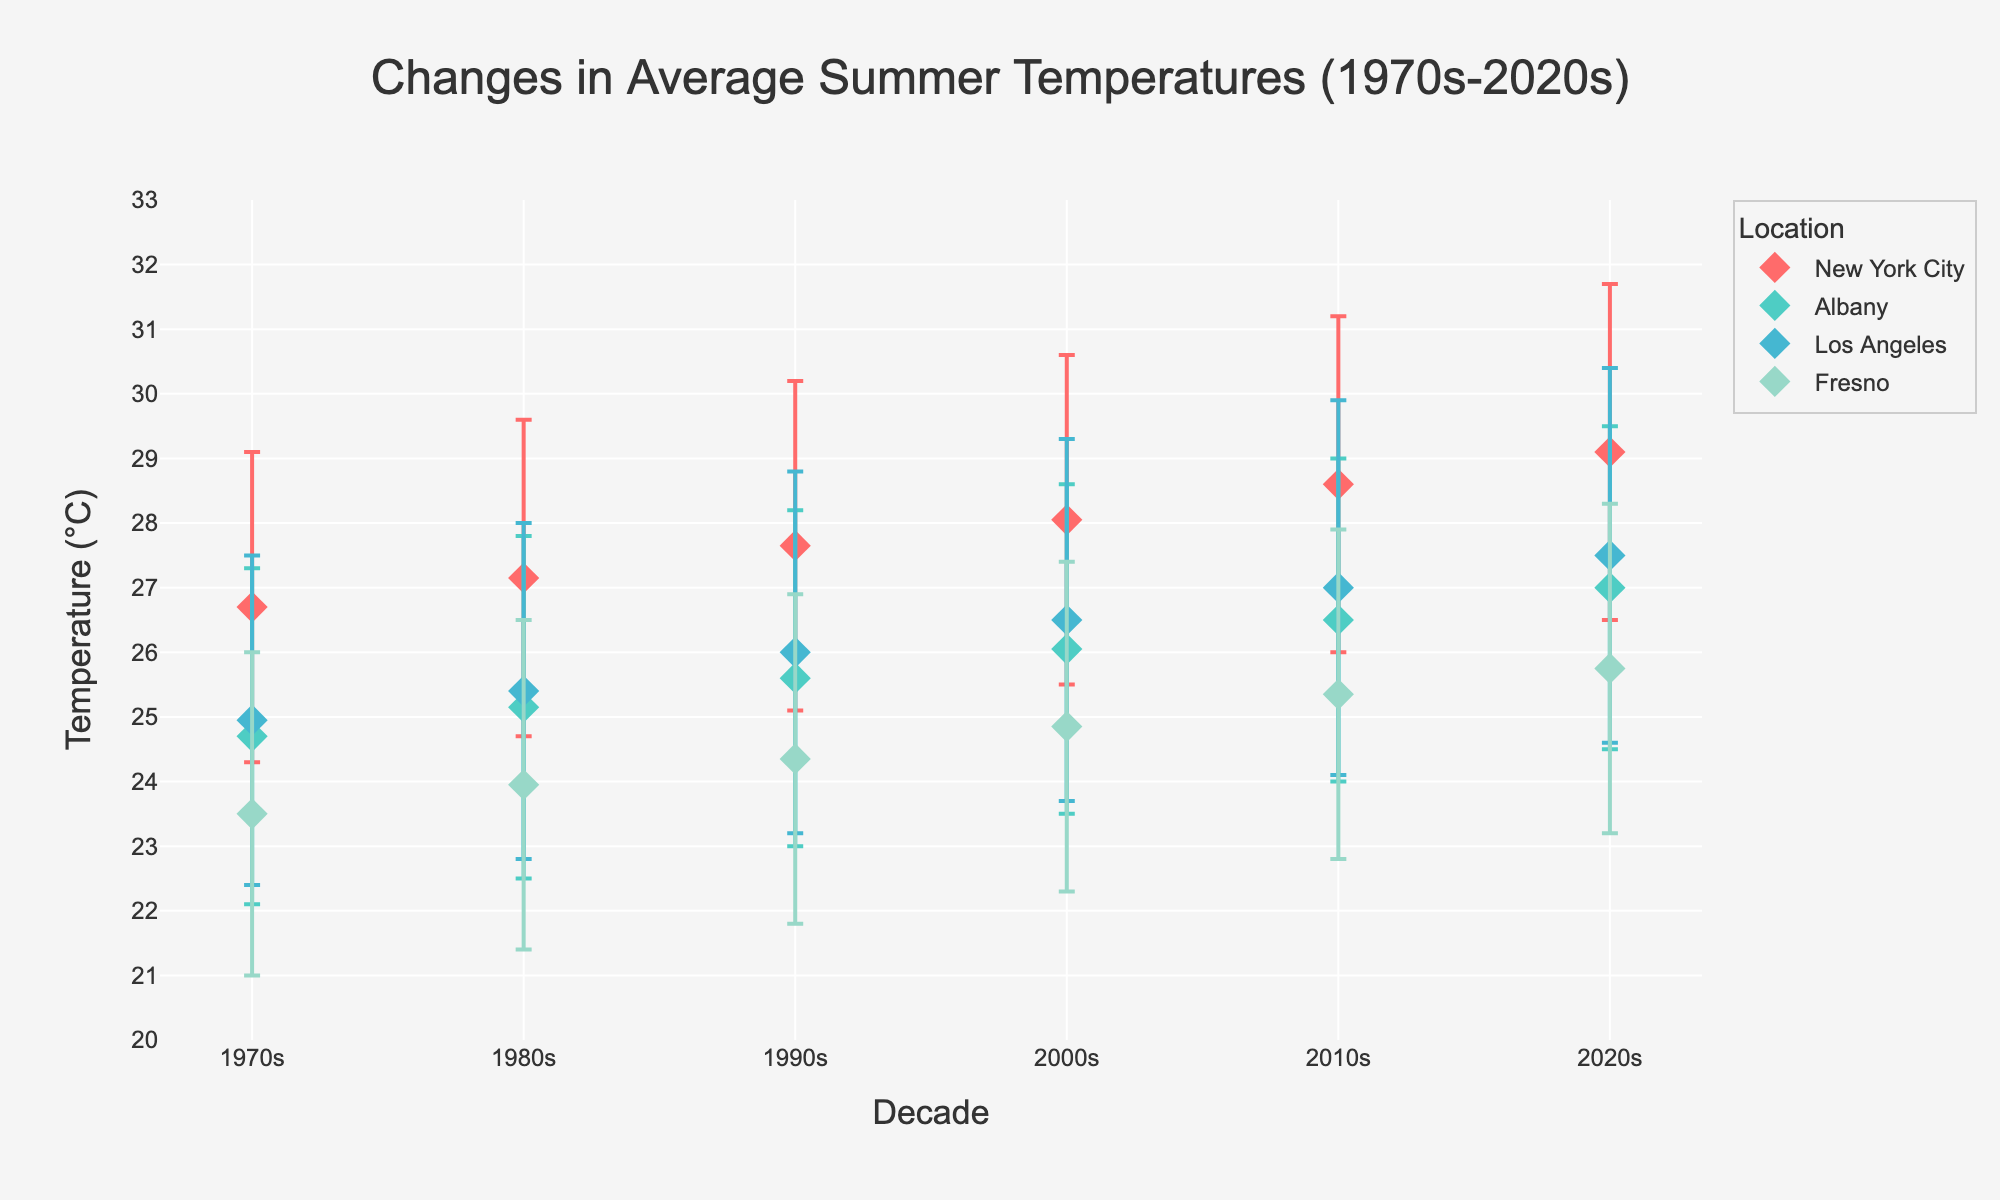What's the title of the figure? The title is centered at the top of the figure. It states the main theme or purpose of the chart.
Answer: Changes in Average Summer Temperatures (1970s-2020s) How many locations are represented in the figure? By observing the number of unique markers corresponding to different labels in the legend, we can count the different locations.
Answer: 4 What is the color assigned to New York City in the figure? The color for each location is distinct and labeled in the legend, where New York City's color is specified.
Answer: Red What are the maximum and minimum temperatures for Albany in the 1990s? Locate the data point for Albany in the 1990s and read off the error bars representing the temperature range. The upper and lower limits of the bar give the max and min temperatures.
Answer: 28.2, 23.0 Which location had the highest maximum temperature in the 2020s? Compare the top ends of the error bars for all locations in the 2020s. The highest point represents the highest maximum temperature.
Answer: New York City How did the average temperature range of Los Angeles change from the 1970s to the 2020s? Look at the error bars for Los Angeles from both decades and compute the difference for both min and max temperatures. The change in the temperature range shows how it evolved.
Answer: Min increased by 2.2°C, Max increased by 2.9°C Which decade shows the smallest temperature range for Fresno? Compare the lengths of the error bars for Fresno across all decades. The decade with the shortest error bar indicates the smallest temperature range.
Answer: 1970s Did rural or urban areas generally show higher summer temperatures in the 2020s? Compare the average points' positions for rural and urban categories within the same decade. Urban areas tend to have higher average points.
Answer: Urban areas By how much did the minimum temperature change in Albany from the 1970s to the 2020s? Subtract the minimum temperature in the 1970s for Albany from the minimum temperature in the 2020s for Albany.
Answer: 2.4°C Which location experienced the least change in maximum temperatures over the decades? The location with the smallest difference between the maximum temperature in the 1970s and the 2020s shows the least change.
Answer: Albany 